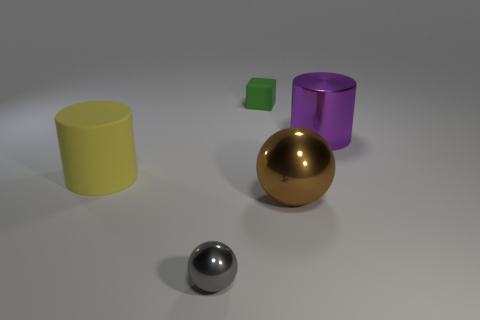Is there anything else that is the same shape as the small green thing? After examining the image carefully, it appears that none of the other objects share the exact same shape as the small green cube. Each item in the image has a distinctive shape, contributing to the diversity of forms presented. 